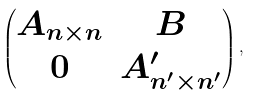Convert formula to latex. <formula><loc_0><loc_0><loc_500><loc_500>\begin{pmatrix} A _ { n \times n } & B \\ 0 & A ^ { \prime } _ { n ^ { \prime } \times n ^ { \prime } } \end{pmatrix} ,</formula> 